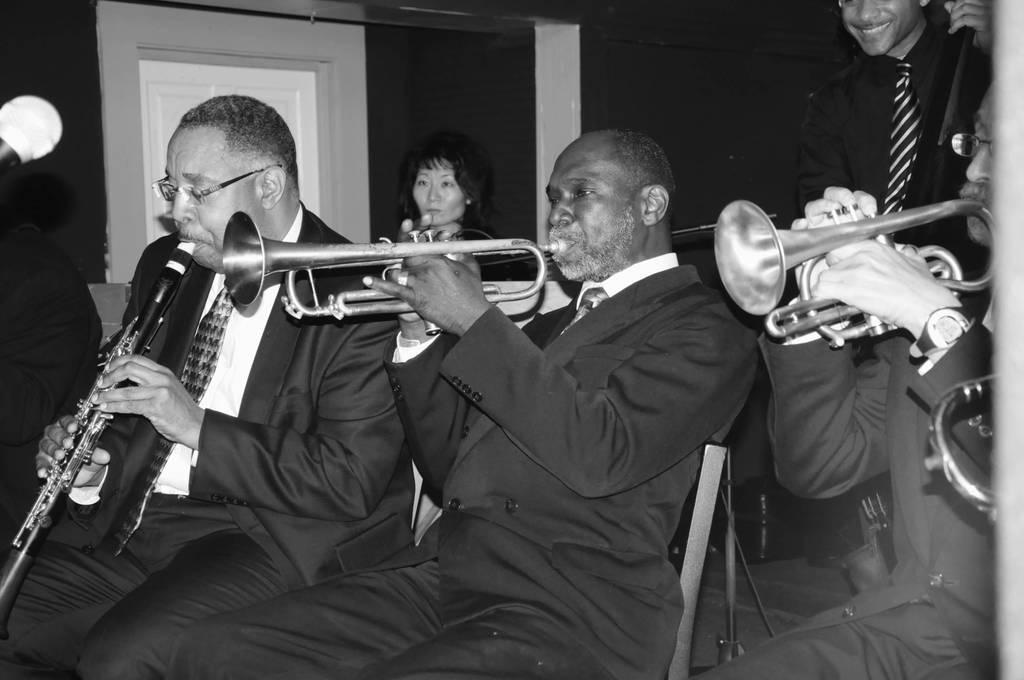Describe this image in one or two sentences. In this image we can see few people sitting on chairs and playing musical instruments. On the left side we can see a mic. On the right side a person is standing. In the back there is a door. And this image is black and white. 